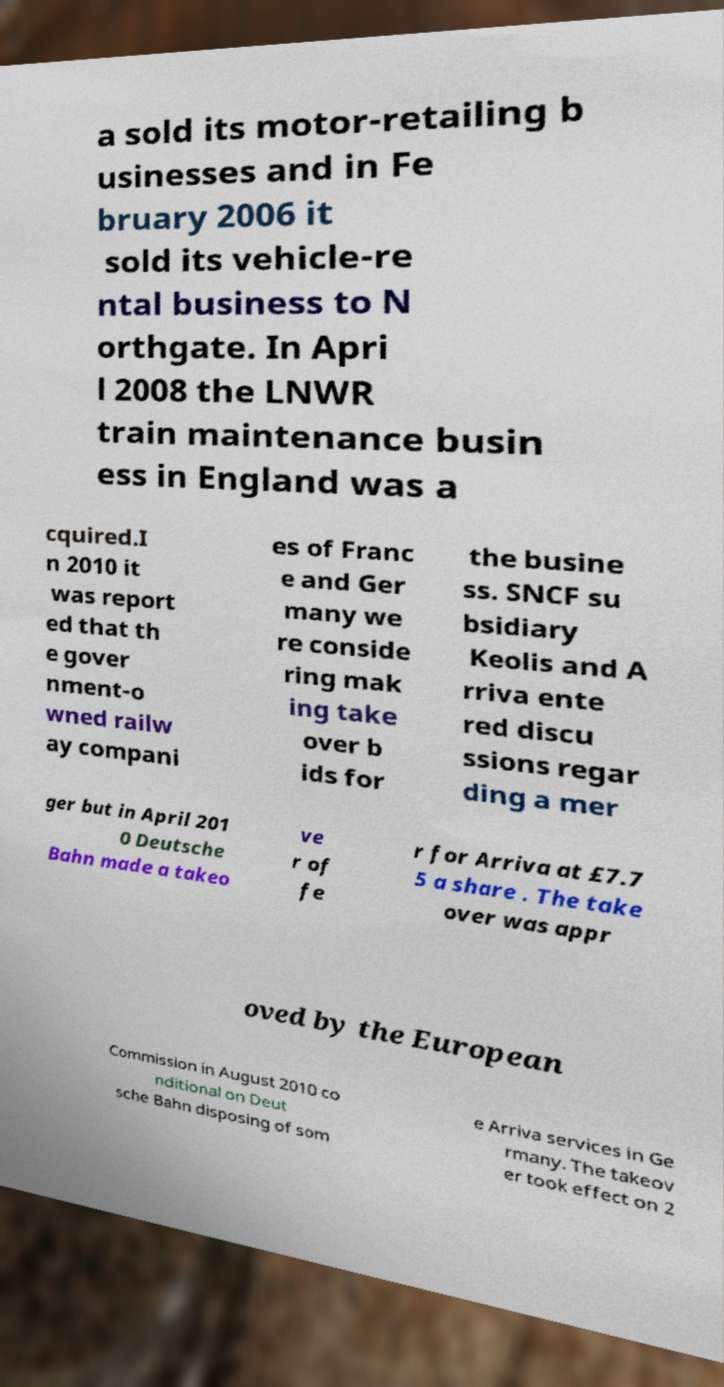Please read and relay the text visible in this image. What does it say? a sold its motor-retailing b usinesses and in Fe bruary 2006 it sold its vehicle-re ntal business to N orthgate. In Apri l 2008 the LNWR train maintenance busin ess in England was a cquired.I n 2010 it was report ed that th e gover nment-o wned railw ay compani es of Franc e and Ger many we re conside ring mak ing take over b ids for the busine ss. SNCF su bsidiary Keolis and A rriva ente red discu ssions regar ding a mer ger but in April 201 0 Deutsche Bahn made a takeo ve r of fe r for Arriva at £7.7 5 a share . The take over was appr oved by the European Commission in August 2010 co nditional on Deut sche Bahn disposing of som e Arriva services in Ge rmany. The takeov er took effect on 2 